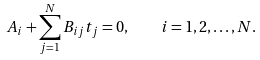<formula> <loc_0><loc_0><loc_500><loc_500>A _ { i } + \sum _ { j = 1 } ^ { N } B _ { i j } t _ { j } = 0 , \quad i = 1 , 2 , \dots , N .</formula> 